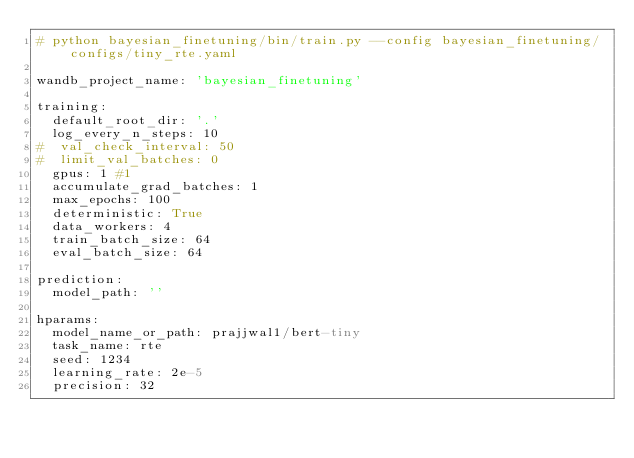Convert code to text. <code><loc_0><loc_0><loc_500><loc_500><_YAML_># python bayesian_finetuning/bin/train.py --config bayesian_finetuning/configs/tiny_rte.yaml

wandb_project_name: 'bayesian_finetuning'

training:
  default_root_dir: '.'
  log_every_n_steps: 10
#  val_check_interval: 50
#  limit_val_batches: 0
  gpus: 1 #1
  accumulate_grad_batches: 1
  max_epochs: 100
  deterministic: True
  data_workers: 4
  train_batch_size: 64
  eval_batch_size: 64

prediction:
  model_path: ''

hparams:
  model_name_or_path: prajjwal1/bert-tiny
  task_name: rte
  seed: 1234
  learning_rate: 2e-5
  precision: 32
</code> 